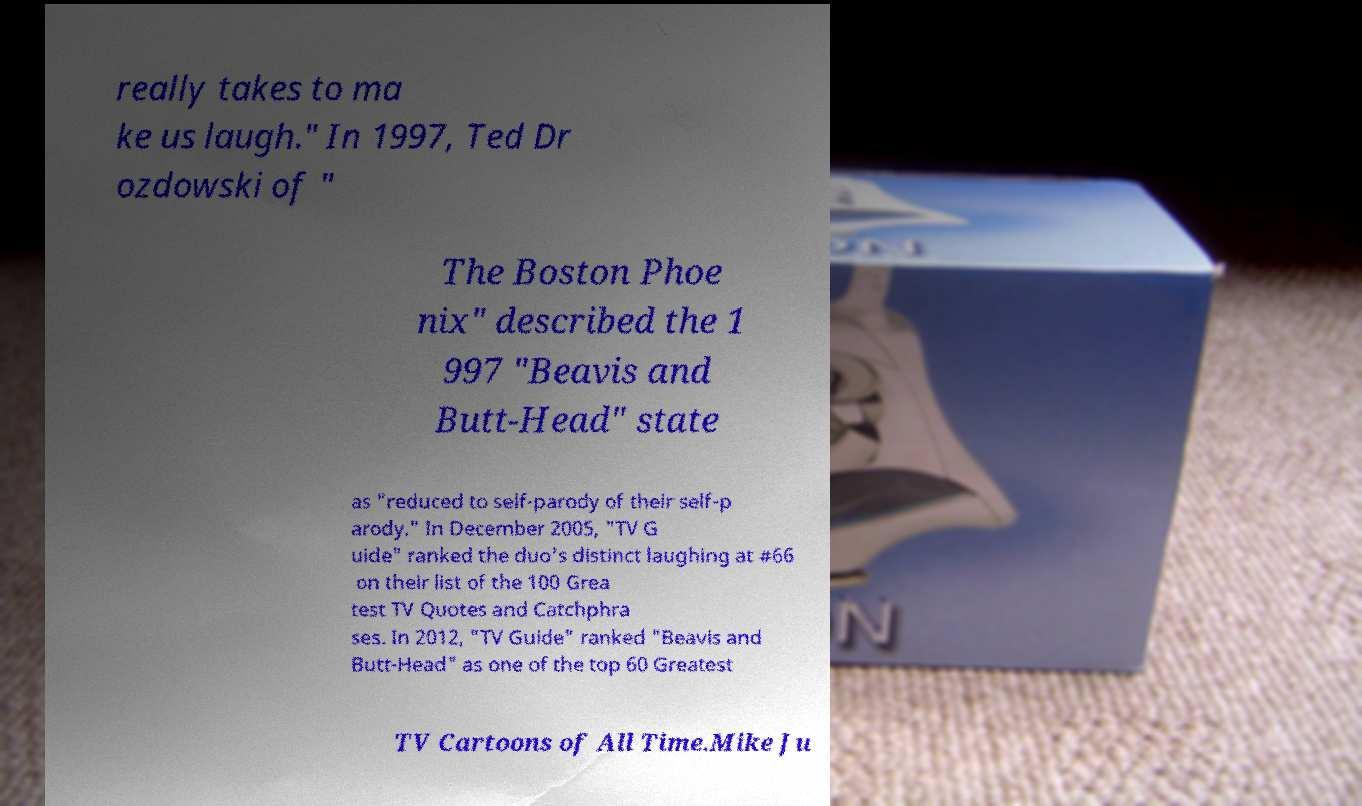Could you assist in decoding the text presented in this image and type it out clearly? really takes to ma ke us laugh." In 1997, Ted Dr ozdowski of " The Boston Phoe nix" described the 1 997 "Beavis and Butt-Head" state as "reduced to self-parody of their self-p arody." In December 2005, "TV G uide" ranked the duo's distinct laughing at #66 on their list of the 100 Grea test TV Quotes and Catchphra ses. In 2012, "TV Guide" ranked "Beavis and Butt-Head" as one of the top 60 Greatest TV Cartoons of All Time.Mike Ju 